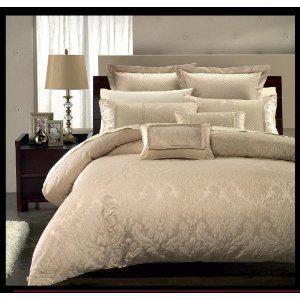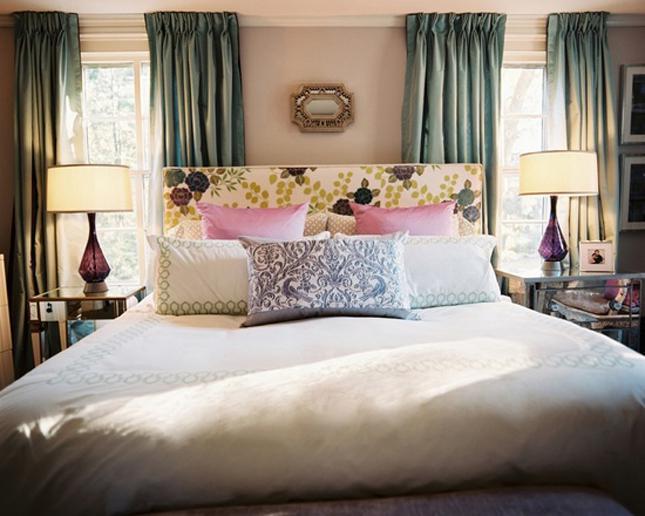The first image is the image on the left, the second image is the image on the right. Considering the images on both sides, is "both bedframes are brown" valid? Answer yes or no. No. 